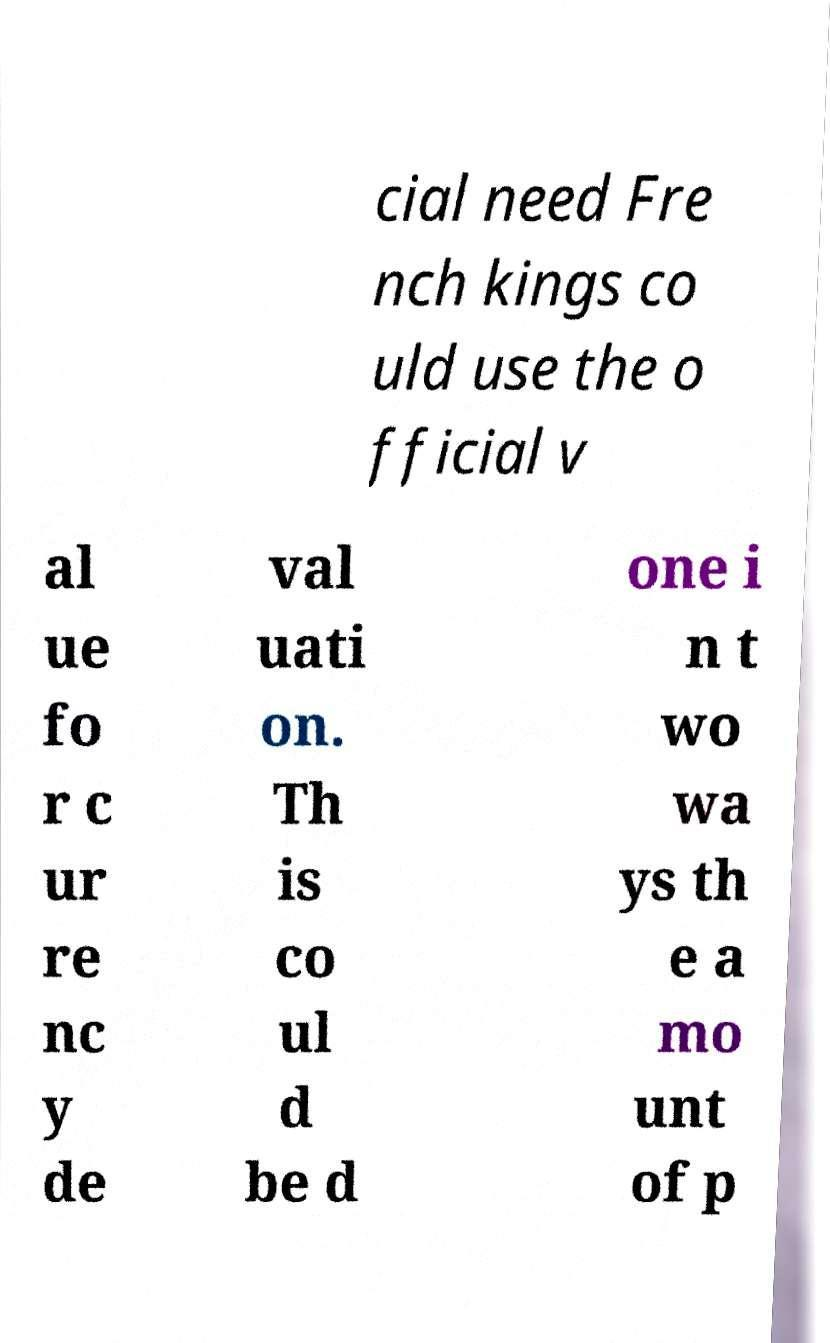Could you extract and type out the text from this image? cial need Fre nch kings co uld use the o fficial v al ue fo r c ur re nc y de val uati on. Th is co ul d be d one i n t wo wa ys th e a mo unt of p 